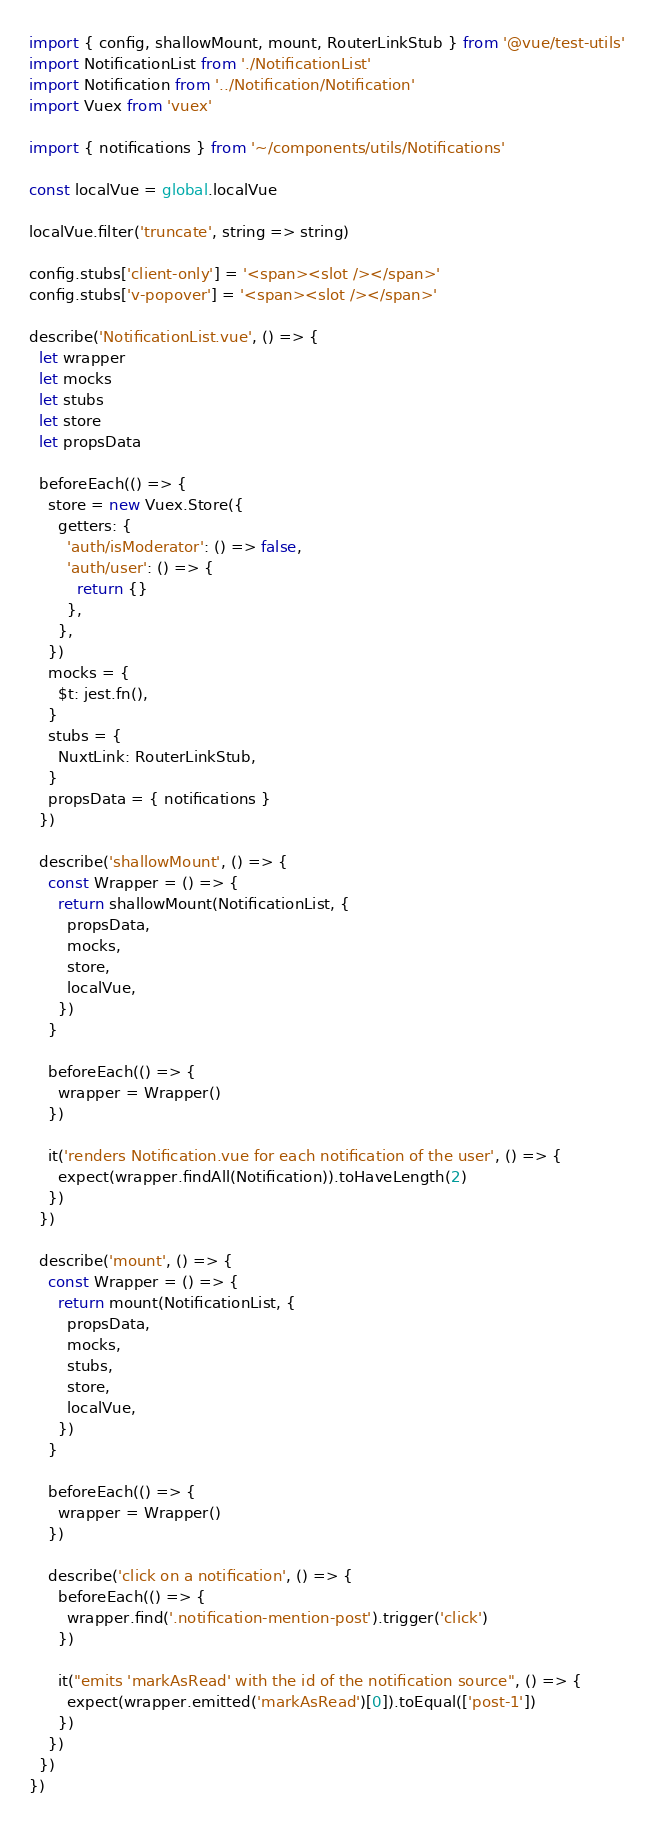<code> <loc_0><loc_0><loc_500><loc_500><_JavaScript_>import { config, shallowMount, mount, RouterLinkStub } from '@vue/test-utils'
import NotificationList from './NotificationList'
import Notification from '../Notification/Notification'
import Vuex from 'vuex'

import { notifications } from '~/components/utils/Notifications'

const localVue = global.localVue

localVue.filter('truncate', string => string)

config.stubs['client-only'] = '<span><slot /></span>'
config.stubs['v-popover'] = '<span><slot /></span>'

describe('NotificationList.vue', () => {
  let wrapper
  let mocks
  let stubs
  let store
  let propsData

  beforeEach(() => {
    store = new Vuex.Store({
      getters: {
        'auth/isModerator': () => false,
        'auth/user': () => {
          return {}
        },
      },
    })
    mocks = {
      $t: jest.fn(),
    }
    stubs = {
      NuxtLink: RouterLinkStub,
    }
    propsData = { notifications }
  })

  describe('shallowMount', () => {
    const Wrapper = () => {
      return shallowMount(NotificationList, {
        propsData,
        mocks,
        store,
        localVue,
      })
    }

    beforeEach(() => {
      wrapper = Wrapper()
    })

    it('renders Notification.vue for each notification of the user', () => {
      expect(wrapper.findAll(Notification)).toHaveLength(2)
    })
  })

  describe('mount', () => {
    const Wrapper = () => {
      return mount(NotificationList, {
        propsData,
        mocks,
        stubs,
        store,
        localVue,
      })
    }

    beforeEach(() => {
      wrapper = Wrapper()
    })

    describe('click on a notification', () => {
      beforeEach(() => {
        wrapper.find('.notification-mention-post').trigger('click')
      })

      it("emits 'markAsRead' with the id of the notification source", () => {
        expect(wrapper.emitted('markAsRead')[0]).toEqual(['post-1'])
      })
    })
  })
})
</code> 